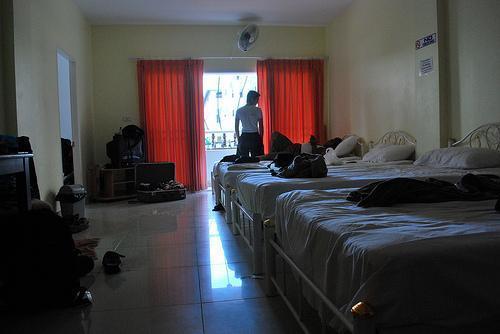How many guys are in the room?
Give a very brief answer. 2. 